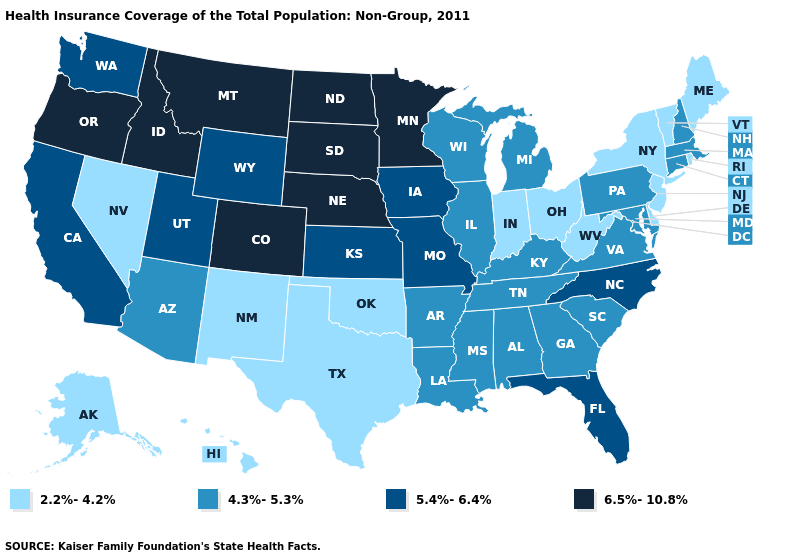Which states have the lowest value in the USA?
Give a very brief answer. Alaska, Delaware, Hawaii, Indiana, Maine, Nevada, New Jersey, New Mexico, New York, Ohio, Oklahoma, Rhode Island, Texas, Vermont, West Virginia. Is the legend a continuous bar?
Keep it brief. No. Name the states that have a value in the range 4.3%-5.3%?
Keep it brief. Alabama, Arizona, Arkansas, Connecticut, Georgia, Illinois, Kentucky, Louisiana, Maryland, Massachusetts, Michigan, Mississippi, New Hampshire, Pennsylvania, South Carolina, Tennessee, Virginia, Wisconsin. What is the value of North Carolina?
Give a very brief answer. 5.4%-6.4%. What is the value of Alaska?
Concise answer only. 2.2%-4.2%. Among the states that border Missouri , does Tennessee have the lowest value?
Give a very brief answer. No. Among the states that border North Carolina , which have the highest value?
Be succinct. Georgia, South Carolina, Tennessee, Virginia. How many symbols are there in the legend?
Answer briefly. 4. What is the highest value in states that border Georgia?
Keep it brief. 5.4%-6.4%. What is the value of Nevada?
Give a very brief answer. 2.2%-4.2%. What is the lowest value in the West?
Short answer required. 2.2%-4.2%. What is the lowest value in states that border Alabama?
Answer briefly. 4.3%-5.3%. Name the states that have a value in the range 4.3%-5.3%?
Be succinct. Alabama, Arizona, Arkansas, Connecticut, Georgia, Illinois, Kentucky, Louisiana, Maryland, Massachusetts, Michigan, Mississippi, New Hampshire, Pennsylvania, South Carolina, Tennessee, Virginia, Wisconsin. What is the lowest value in the West?
Write a very short answer. 2.2%-4.2%. Which states have the highest value in the USA?
Write a very short answer. Colorado, Idaho, Minnesota, Montana, Nebraska, North Dakota, Oregon, South Dakota. 